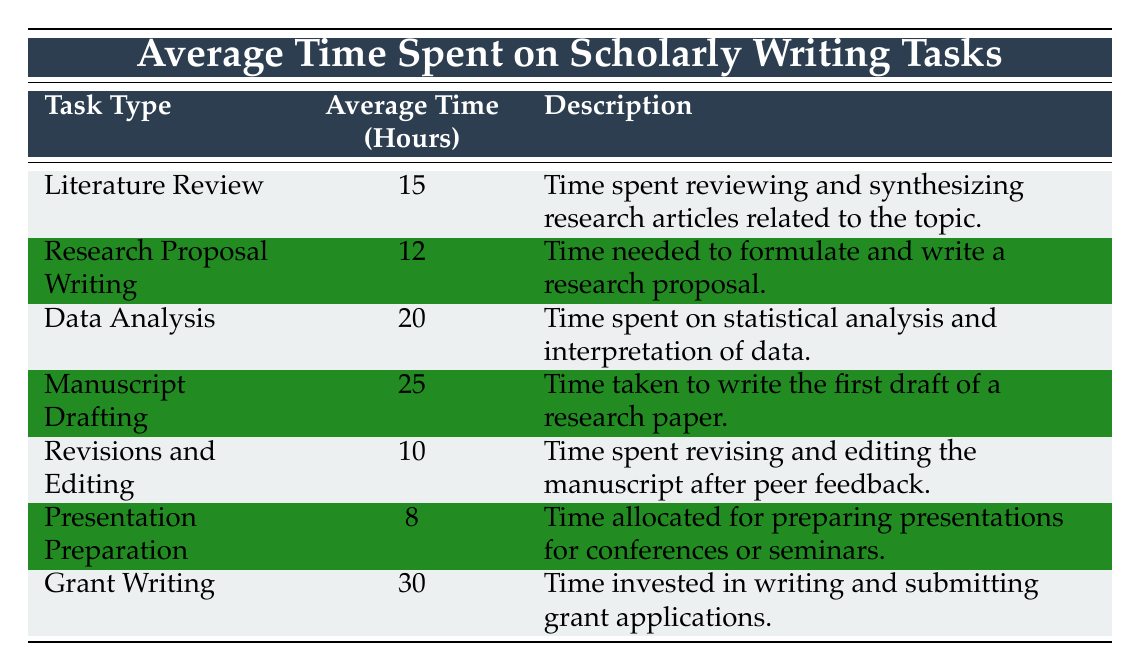What is the average time spent on data analysis? According to the table, the average time for data analysis is explicitly listed as 20 hours.
Answer: 20 hours Which task type requires the least amount of time? The table indicates that presentation preparation requires the least amount of time with an average of 8 hours.
Answer: Presentation preparation Is the average time spent on manuscript drafting greater than the average time spent on literature review? The average time for manuscript drafting is 25 hours and for literature review, it is 15 hours. Since 25 is greater than 15, it confirms that manuscript drafting takes more time.
Answer: Yes What is the total time spent on literature review and revisions and editing combined? The time for literature review is 15 hours, and for revisions and editing, it is 10 hours. Adding them gives us 15 + 10 = 25 hours.
Answer: 25 hours Is the average time for grant writing less than the total of the average times for presentation preparation and research proposal writing? The time for grant writing is 30 hours, while presentation preparation is 8 hours and research proposal writing is 12 hours. The total of the latter two is 8 + 12 = 20 hours, which is less than 30.
Answer: No What is the average time spent on writing tasks excluding data analysis? The times for the tasks excluding data analysis are: literature review (15), research proposal writing (12), manuscript drafting (25), revisions and editing (10), and presentation preparation (8). Summing these gives 15 + 12 + 25 + 10 + 8 = 70. There are five tasks, so the average is 70 / 5 = 14 hours.
Answer: 14 hours How does the average time spent on revisions and editing compare to the time spent on grant writing? The average time for revisions and editing is 10 hours, while grant writing takes 30 hours. Since 10 is less than 30, revisions take less time.
Answer: Revisions take less time What is the difference between the average time spent on data analysis and manuscript drafting? Data analysis takes 20 hours and manuscript drafting takes 25 hours. The difference is 25 - 20 = 5 hours.
Answer: 5 hours 